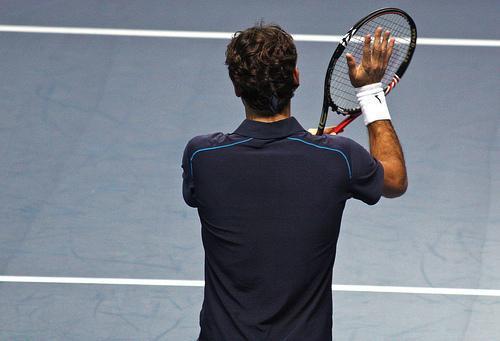How many people are in the photo?
Give a very brief answer. 1. 